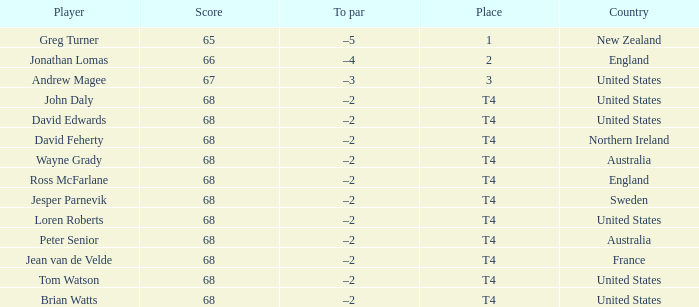Who has a To par of –2, and a Country of united states? John Daly, David Edwards, Loren Roberts, Tom Watson, Brian Watts. Write the full table. {'header': ['Player', 'Score', 'To par', 'Place', 'Country'], 'rows': [['Greg Turner', '65', '–5', '1', 'New Zealand'], ['Jonathan Lomas', '66', '–4', '2', 'England'], ['Andrew Magee', '67', '–3', '3', 'United States'], ['John Daly', '68', '–2', 'T4', 'United States'], ['David Edwards', '68', '–2', 'T4', 'United States'], ['David Feherty', '68', '–2', 'T4', 'Northern Ireland'], ['Wayne Grady', '68', '–2', 'T4', 'Australia'], ['Ross McFarlane', '68', '–2', 'T4', 'England'], ['Jesper Parnevik', '68', '–2', 'T4', 'Sweden'], ['Loren Roberts', '68', '–2', 'T4', 'United States'], ['Peter Senior', '68', '–2', 'T4', 'Australia'], ['Jean van de Velde', '68', '–2', 'T4', 'France'], ['Tom Watson', '68', '–2', 'T4', 'United States'], ['Brian Watts', '68', '–2', 'T4', 'United States']]} 